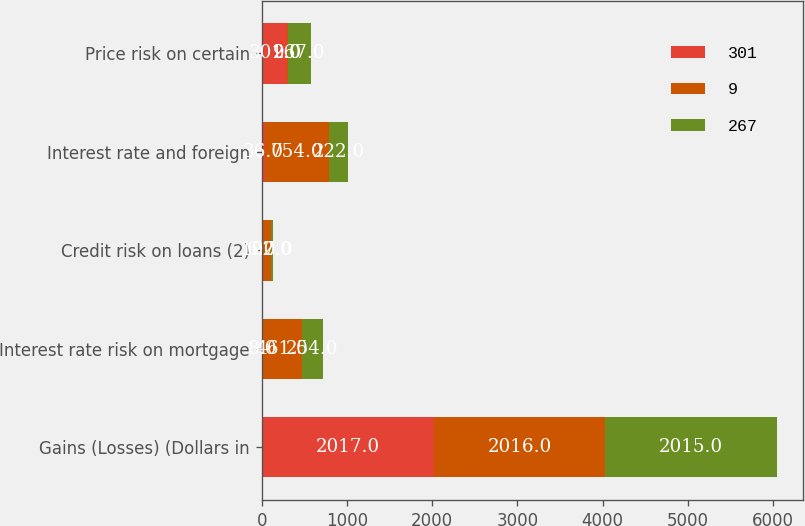Convert chart to OTSL. <chart><loc_0><loc_0><loc_500><loc_500><stacked_bar_chart><ecel><fcel>Gains (Losses) (Dollars in<fcel>Interest rate risk on mortgage<fcel>Credit risk on loans (2)<fcel>Interest rate and foreign<fcel>Price risk on certain<nl><fcel>301<fcel>2017<fcel>8<fcel>6<fcel>36<fcel>301<nl><fcel>9<fcel>2016<fcel>461<fcel>107<fcel>754<fcel>9<nl><fcel>267<fcel>2015<fcel>254<fcel>22<fcel>222<fcel>267<nl></chart> 